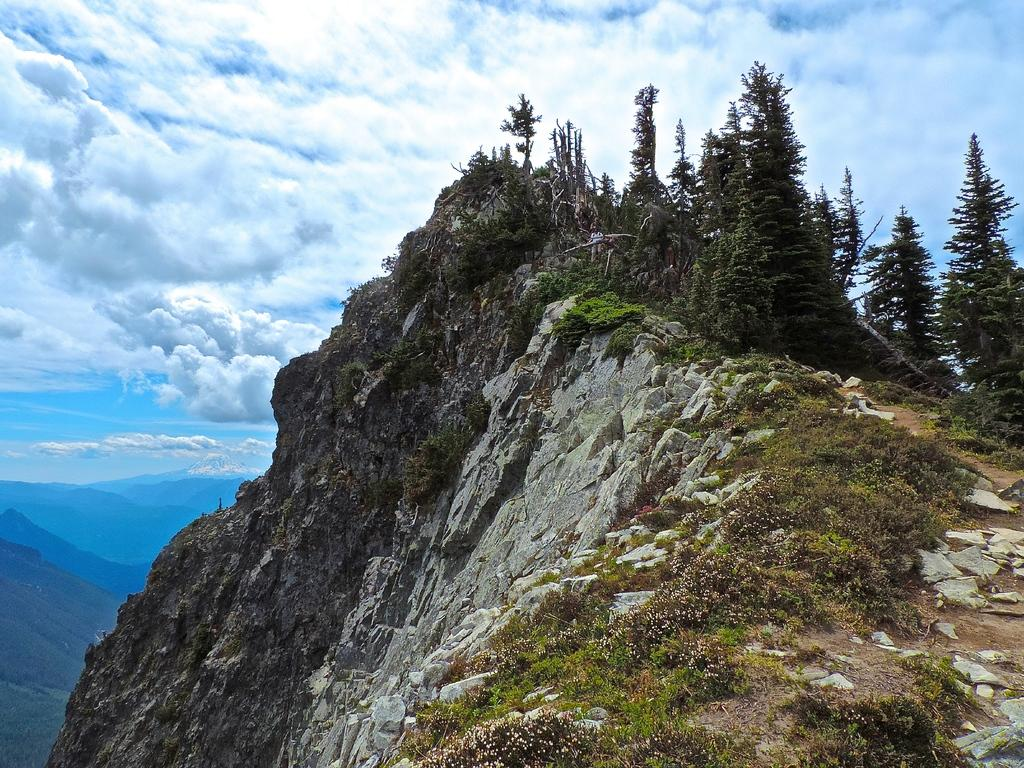What geographical feature is the main subject of the image? There is a mountain in the image. What type of vegetation can be seen in the image? There are plants and trees in the image. Are there any other mountains visible in the image? Yes, there are more mountains in the background of the image. What is the condition of the sky in the image? The sky is clear in the image. What type of society can be seen living on the mountain in the image? There is no society visible in the image; it only features a mountain, plants, trees, and a clear sky. What substance is being delivered by the parcel visible in the image? There is no parcel present in the image. 